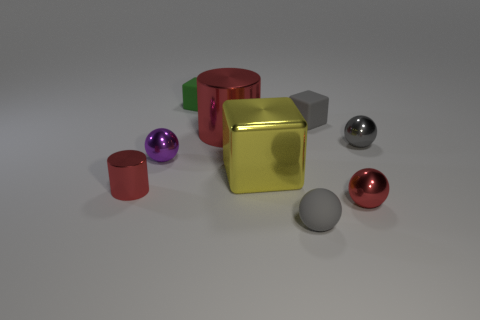What can you infer about the different materials used for these objects? Based on the reflections and sheen, the spheres and cylinders appear to be made of a metallic material, while the cubes seem to have a matte finish, suggesting a possible plastic or rubber composition. Which object stands out the most to you, and why? The gold cube stands out due to its central position, distinct color, and reflective metallic surface which contrasts with the other objects' colors and materials. 